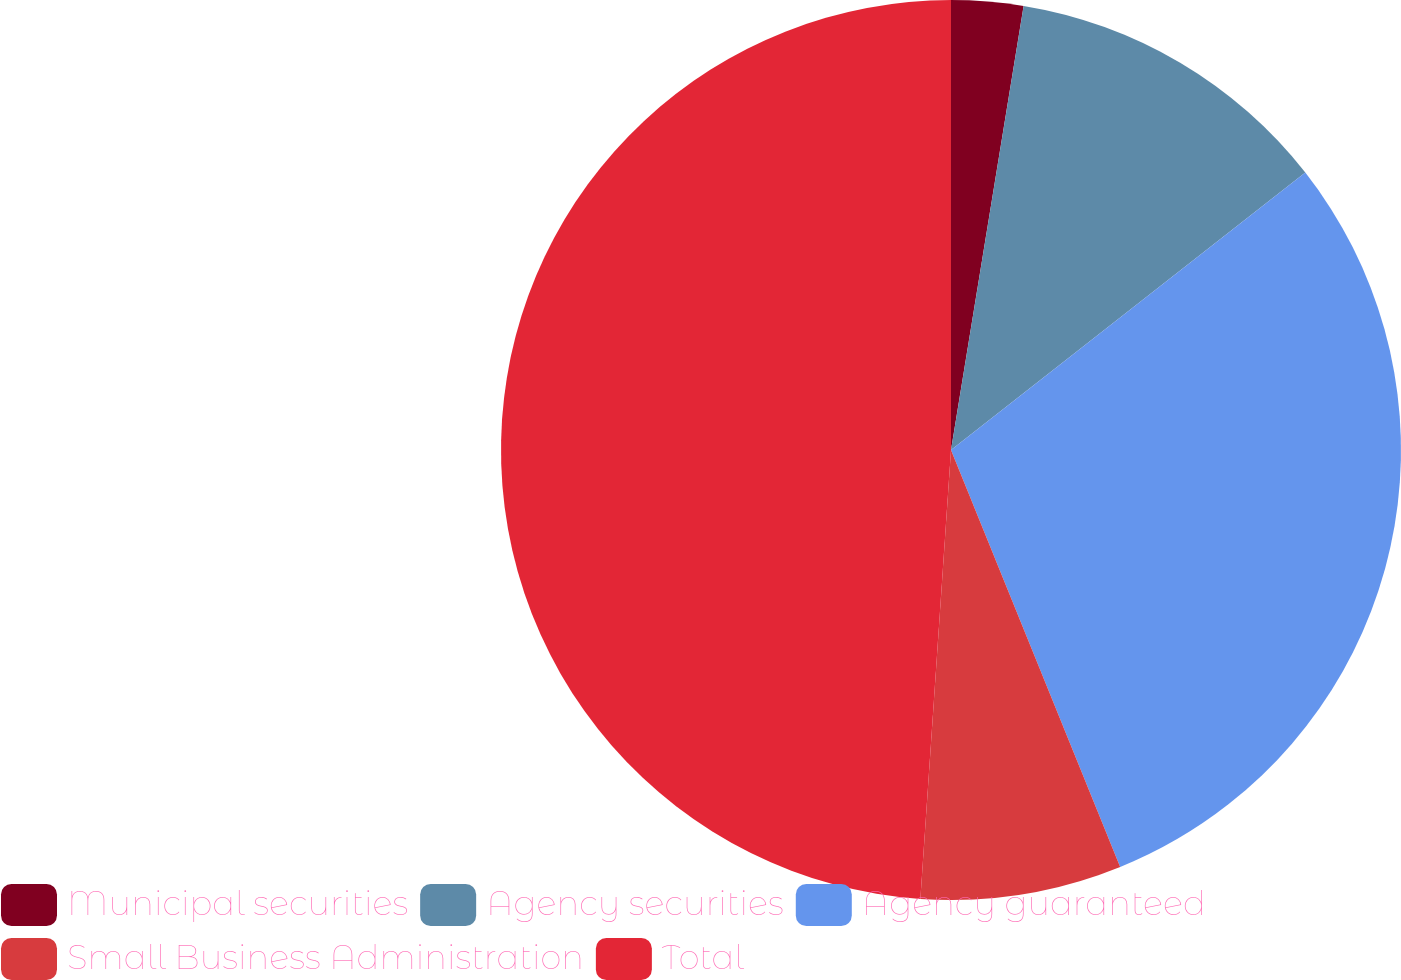Convert chart. <chart><loc_0><loc_0><loc_500><loc_500><pie_chart><fcel>Municipal securities<fcel>Agency securities<fcel>Agency guaranteed<fcel>Small Business Administration<fcel>Total<nl><fcel>2.58%<fcel>11.85%<fcel>29.44%<fcel>7.22%<fcel>48.92%<nl></chart> 